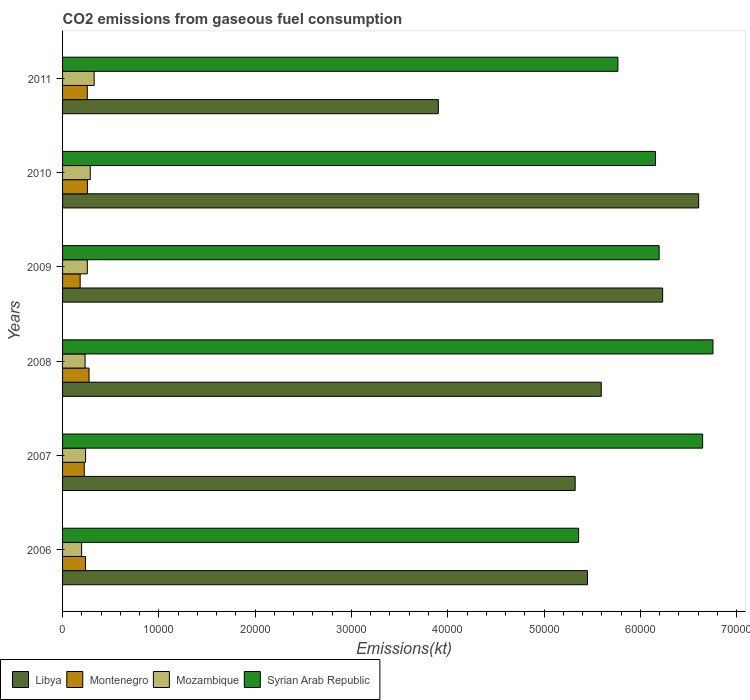How many different coloured bars are there?
Your response must be concise. 4. Are the number of bars per tick equal to the number of legend labels?
Your response must be concise. Yes. In how many cases, is the number of bars for a given year not equal to the number of legend labels?
Your response must be concise. 0. What is the amount of CO2 emitted in Montenegro in 2010?
Ensure brevity in your answer.  2581.57. Across all years, what is the maximum amount of CO2 emitted in Syrian Arab Republic?
Keep it short and to the point. 6.75e+04. Across all years, what is the minimum amount of CO2 emitted in Montenegro?
Offer a very short reply. 1826.17. In which year was the amount of CO2 emitted in Syrian Arab Republic maximum?
Keep it short and to the point. 2008. What is the total amount of CO2 emitted in Mozambique in the graph?
Provide a short and direct response. 1.54e+04. What is the difference between the amount of CO2 emitted in Montenegro in 2007 and that in 2008?
Your response must be concise. -498.71. What is the difference between the amount of CO2 emitted in Mozambique in 2010 and the amount of CO2 emitted in Montenegro in 2007?
Your answer should be very brief. 623.39. What is the average amount of CO2 emitted in Mozambique per year?
Provide a short and direct response. 2573.01. In the year 2007, what is the difference between the amount of CO2 emitted in Libya and amount of CO2 emitted in Syrian Arab Republic?
Ensure brevity in your answer.  -1.32e+04. In how many years, is the amount of CO2 emitted in Mozambique greater than 2000 kt?
Keep it short and to the point. 5. What is the ratio of the amount of CO2 emitted in Libya in 2008 to that in 2011?
Give a very brief answer. 1.43. What is the difference between the highest and the second highest amount of CO2 emitted in Mozambique?
Provide a succinct answer. 407.04. What is the difference between the highest and the lowest amount of CO2 emitted in Libya?
Keep it short and to the point. 2.70e+04. In how many years, is the amount of CO2 emitted in Montenegro greater than the average amount of CO2 emitted in Montenegro taken over all years?
Give a very brief answer. 3. Is the sum of the amount of CO2 emitted in Syrian Arab Republic in 2008 and 2011 greater than the maximum amount of CO2 emitted in Montenegro across all years?
Make the answer very short. Yes. What does the 3rd bar from the top in 2009 represents?
Provide a succinct answer. Montenegro. What does the 1st bar from the bottom in 2009 represents?
Your answer should be compact. Libya. Is it the case that in every year, the sum of the amount of CO2 emitted in Syrian Arab Republic and amount of CO2 emitted in Montenegro is greater than the amount of CO2 emitted in Mozambique?
Your answer should be compact. Yes. How many bars are there?
Make the answer very short. 24. Are all the bars in the graph horizontal?
Ensure brevity in your answer.  Yes. How many years are there in the graph?
Your answer should be compact. 6. What is the difference between two consecutive major ticks on the X-axis?
Provide a succinct answer. 10000. Does the graph contain any zero values?
Keep it short and to the point. No. Where does the legend appear in the graph?
Offer a terse response. Bottom left. How are the legend labels stacked?
Your answer should be very brief. Horizontal. What is the title of the graph?
Give a very brief answer. CO2 emissions from gaseous fuel consumption. What is the label or title of the X-axis?
Your answer should be very brief. Emissions(kt). What is the Emissions(kt) in Libya in 2006?
Make the answer very short. 5.45e+04. What is the Emissions(kt) in Montenegro in 2006?
Ensure brevity in your answer.  2383.55. What is the Emissions(kt) in Mozambique in 2006?
Keep it short and to the point. 1980.18. What is the Emissions(kt) in Syrian Arab Republic in 2006?
Your response must be concise. 5.36e+04. What is the Emissions(kt) in Libya in 2007?
Your response must be concise. 5.32e+04. What is the Emissions(kt) of Montenegro in 2007?
Give a very brief answer. 2251.54. What is the Emissions(kt) of Mozambique in 2007?
Provide a succinct answer. 2390.88. What is the Emissions(kt) in Syrian Arab Republic in 2007?
Make the answer very short. 6.65e+04. What is the Emissions(kt) of Libya in 2008?
Provide a short and direct response. 5.59e+04. What is the Emissions(kt) in Montenegro in 2008?
Provide a succinct answer. 2750.25. What is the Emissions(kt) in Mozambique in 2008?
Provide a succinct answer. 2339.55. What is the Emissions(kt) of Syrian Arab Republic in 2008?
Give a very brief answer. 6.75e+04. What is the Emissions(kt) in Libya in 2009?
Offer a terse response. 6.23e+04. What is the Emissions(kt) of Montenegro in 2009?
Keep it short and to the point. 1826.17. What is the Emissions(kt) of Mozambique in 2009?
Ensure brevity in your answer.  2570.57. What is the Emissions(kt) of Syrian Arab Republic in 2009?
Provide a short and direct response. 6.20e+04. What is the Emissions(kt) of Libya in 2010?
Give a very brief answer. 6.61e+04. What is the Emissions(kt) of Montenegro in 2010?
Make the answer very short. 2581.57. What is the Emissions(kt) of Mozambique in 2010?
Offer a terse response. 2874.93. What is the Emissions(kt) in Syrian Arab Republic in 2010?
Your answer should be very brief. 6.16e+04. What is the Emissions(kt) in Libya in 2011?
Provide a succinct answer. 3.90e+04. What is the Emissions(kt) of Montenegro in 2011?
Give a very brief answer. 2570.57. What is the Emissions(kt) in Mozambique in 2011?
Make the answer very short. 3281.97. What is the Emissions(kt) of Syrian Arab Republic in 2011?
Offer a very short reply. 5.77e+04. Across all years, what is the maximum Emissions(kt) of Libya?
Ensure brevity in your answer.  6.61e+04. Across all years, what is the maximum Emissions(kt) of Montenegro?
Your response must be concise. 2750.25. Across all years, what is the maximum Emissions(kt) in Mozambique?
Your response must be concise. 3281.97. Across all years, what is the maximum Emissions(kt) in Syrian Arab Republic?
Your answer should be compact. 6.75e+04. Across all years, what is the minimum Emissions(kt) in Libya?
Your answer should be very brief. 3.90e+04. Across all years, what is the minimum Emissions(kt) of Montenegro?
Offer a terse response. 1826.17. Across all years, what is the minimum Emissions(kt) in Mozambique?
Your answer should be compact. 1980.18. Across all years, what is the minimum Emissions(kt) in Syrian Arab Republic?
Keep it short and to the point. 5.36e+04. What is the total Emissions(kt) in Libya in the graph?
Offer a very short reply. 3.31e+05. What is the total Emissions(kt) of Montenegro in the graph?
Your answer should be compact. 1.44e+04. What is the total Emissions(kt) in Mozambique in the graph?
Your answer should be compact. 1.54e+04. What is the total Emissions(kt) of Syrian Arab Republic in the graph?
Make the answer very short. 3.69e+05. What is the difference between the Emissions(kt) in Libya in 2006 and that in 2007?
Keep it short and to the point. 1279.78. What is the difference between the Emissions(kt) in Montenegro in 2006 and that in 2007?
Offer a terse response. 132.01. What is the difference between the Emissions(kt) in Mozambique in 2006 and that in 2007?
Keep it short and to the point. -410.7. What is the difference between the Emissions(kt) in Syrian Arab Republic in 2006 and that in 2007?
Offer a very short reply. -1.29e+04. What is the difference between the Emissions(kt) of Libya in 2006 and that in 2008?
Give a very brief answer. -1433.8. What is the difference between the Emissions(kt) in Montenegro in 2006 and that in 2008?
Your answer should be compact. -366.7. What is the difference between the Emissions(kt) in Mozambique in 2006 and that in 2008?
Provide a short and direct response. -359.37. What is the difference between the Emissions(kt) of Syrian Arab Republic in 2006 and that in 2008?
Ensure brevity in your answer.  -1.40e+04. What is the difference between the Emissions(kt) of Libya in 2006 and that in 2009?
Offer a very short reply. -7807.04. What is the difference between the Emissions(kt) in Montenegro in 2006 and that in 2009?
Provide a succinct answer. 557.38. What is the difference between the Emissions(kt) of Mozambique in 2006 and that in 2009?
Offer a very short reply. -590.39. What is the difference between the Emissions(kt) of Syrian Arab Republic in 2006 and that in 2009?
Provide a short and direct response. -8364.43. What is the difference between the Emissions(kt) in Libya in 2006 and that in 2010?
Offer a terse response. -1.15e+04. What is the difference between the Emissions(kt) in Montenegro in 2006 and that in 2010?
Your response must be concise. -198.02. What is the difference between the Emissions(kt) of Mozambique in 2006 and that in 2010?
Give a very brief answer. -894.75. What is the difference between the Emissions(kt) in Syrian Arab Republic in 2006 and that in 2010?
Provide a succinct answer. -7986.73. What is the difference between the Emissions(kt) in Libya in 2006 and that in 2011?
Your answer should be very brief. 1.55e+04. What is the difference between the Emissions(kt) in Montenegro in 2006 and that in 2011?
Your answer should be very brief. -187.02. What is the difference between the Emissions(kt) of Mozambique in 2006 and that in 2011?
Offer a terse response. -1301.79. What is the difference between the Emissions(kt) of Syrian Arab Republic in 2006 and that in 2011?
Provide a succinct answer. -4081.37. What is the difference between the Emissions(kt) in Libya in 2007 and that in 2008?
Your answer should be compact. -2713.58. What is the difference between the Emissions(kt) in Montenegro in 2007 and that in 2008?
Give a very brief answer. -498.71. What is the difference between the Emissions(kt) in Mozambique in 2007 and that in 2008?
Provide a succinct answer. 51.34. What is the difference between the Emissions(kt) of Syrian Arab Republic in 2007 and that in 2008?
Your response must be concise. -1074.43. What is the difference between the Emissions(kt) in Libya in 2007 and that in 2009?
Provide a short and direct response. -9086.83. What is the difference between the Emissions(kt) of Montenegro in 2007 and that in 2009?
Make the answer very short. 425.37. What is the difference between the Emissions(kt) of Mozambique in 2007 and that in 2009?
Your answer should be compact. -179.68. What is the difference between the Emissions(kt) in Syrian Arab Republic in 2007 and that in 2009?
Offer a terse response. 4514.08. What is the difference between the Emissions(kt) of Libya in 2007 and that in 2010?
Your response must be concise. -1.28e+04. What is the difference between the Emissions(kt) of Montenegro in 2007 and that in 2010?
Provide a succinct answer. -330.03. What is the difference between the Emissions(kt) in Mozambique in 2007 and that in 2010?
Offer a terse response. -484.04. What is the difference between the Emissions(kt) of Syrian Arab Republic in 2007 and that in 2010?
Your response must be concise. 4891.78. What is the difference between the Emissions(kt) in Libya in 2007 and that in 2011?
Ensure brevity in your answer.  1.42e+04. What is the difference between the Emissions(kt) of Montenegro in 2007 and that in 2011?
Make the answer very short. -319.03. What is the difference between the Emissions(kt) in Mozambique in 2007 and that in 2011?
Offer a terse response. -891.08. What is the difference between the Emissions(kt) in Syrian Arab Republic in 2007 and that in 2011?
Provide a succinct answer. 8797.13. What is the difference between the Emissions(kt) in Libya in 2008 and that in 2009?
Provide a succinct answer. -6373.25. What is the difference between the Emissions(kt) of Montenegro in 2008 and that in 2009?
Your response must be concise. 924.08. What is the difference between the Emissions(kt) in Mozambique in 2008 and that in 2009?
Offer a terse response. -231.02. What is the difference between the Emissions(kt) in Syrian Arab Republic in 2008 and that in 2009?
Your answer should be compact. 5588.51. What is the difference between the Emissions(kt) in Libya in 2008 and that in 2010?
Provide a succinct answer. -1.01e+04. What is the difference between the Emissions(kt) in Montenegro in 2008 and that in 2010?
Keep it short and to the point. 168.68. What is the difference between the Emissions(kt) of Mozambique in 2008 and that in 2010?
Give a very brief answer. -535.38. What is the difference between the Emissions(kt) of Syrian Arab Republic in 2008 and that in 2010?
Offer a terse response. 5966.21. What is the difference between the Emissions(kt) in Libya in 2008 and that in 2011?
Provide a succinct answer. 1.69e+04. What is the difference between the Emissions(kt) of Montenegro in 2008 and that in 2011?
Provide a succinct answer. 179.68. What is the difference between the Emissions(kt) of Mozambique in 2008 and that in 2011?
Make the answer very short. -942.42. What is the difference between the Emissions(kt) of Syrian Arab Republic in 2008 and that in 2011?
Offer a terse response. 9871.56. What is the difference between the Emissions(kt) of Libya in 2009 and that in 2010?
Offer a very short reply. -3740.34. What is the difference between the Emissions(kt) of Montenegro in 2009 and that in 2010?
Offer a terse response. -755.4. What is the difference between the Emissions(kt) of Mozambique in 2009 and that in 2010?
Offer a terse response. -304.36. What is the difference between the Emissions(kt) in Syrian Arab Republic in 2009 and that in 2010?
Provide a succinct answer. 377.7. What is the difference between the Emissions(kt) of Libya in 2009 and that in 2011?
Your answer should be compact. 2.33e+04. What is the difference between the Emissions(kt) of Montenegro in 2009 and that in 2011?
Your answer should be very brief. -744.4. What is the difference between the Emissions(kt) of Mozambique in 2009 and that in 2011?
Provide a short and direct response. -711.4. What is the difference between the Emissions(kt) of Syrian Arab Republic in 2009 and that in 2011?
Make the answer very short. 4283.06. What is the difference between the Emissions(kt) of Libya in 2010 and that in 2011?
Your answer should be compact. 2.70e+04. What is the difference between the Emissions(kt) in Montenegro in 2010 and that in 2011?
Offer a terse response. 11. What is the difference between the Emissions(kt) of Mozambique in 2010 and that in 2011?
Your answer should be very brief. -407.04. What is the difference between the Emissions(kt) in Syrian Arab Republic in 2010 and that in 2011?
Provide a short and direct response. 3905.36. What is the difference between the Emissions(kt) of Libya in 2006 and the Emissions(kt) of Montenegro in 2007?
Give a very brief answer. 5.23e+04. What is the difference between the Emissions(kt) in Libya in 2006 and the Emissions(kt) in Mozambique in 2007?
Ensure brevity in your answer.  5.21e+04. What is the difference between the Emissions(kt) of Libya in 2006 and the Emissions(kt) of Syrian Arab Republic in 2007?
Keep it short and to the point. -1.20e+04. What is the difference between the Emissions(kt) in Montenegro in 2006 and the Emissions(kt) in Mozambique in 2007?
Offer a very short reply. -7.33. What is the difference between the Emissions(kt) of Montenegro in 2006 and the Emissions(kt) of Syrian Arab Republic in 2007?
Your answer should be very brief. -6.41e+04. What is the difference between the Emissions(kt) of Mozambique in 2006 and the Emissions(kt) of Syrian Arab Republic in 2007?
Provide a succinct answer. -6.45e+04. What is the difference between the Emissions(kt) of Libya in 2006 and the Emissions(kt) of Montenegro in 2008?
Provide a succinct answer. 5.18e+04. What is the difference between the Emissions(kt) in Libya in 2006 and the Emissions(kt) in Mozambique in 2008?
Your answer should be very brief. 5.22e+04. What is the difference between the Emissions(kt) of Libya in 2006 and the Emissions(kt) of Syrian Arab Republic in 2008?
Your response must be concise. -1.30e+04. What is the difference between the Emissions(kt) of Montenegro in 2006 and the Emissions(kt) of Mozambique in 2008?
Make the answer very short. 44. What is the difference between the Emissions(kt) of Montenegro in 2006 and the Emissions(kt) of Syrian Arab Republic in 2008?
Ensure brevity in your answer.  -6.52e+04. What is the difference between the Emissions(kt) in Mozambique in 2006 and the Emissions(kt) in Syrian Arab Republic in 2008?
Offer a terse response. -6.56e+04. What is the difference between the Emissions(kt) in Libya in 2006 and the Emissions(kt) in Montenegro in 2009?
Your response must be concise. 5.27e+04. What is the difference between the Emissions(kt) in Libya in 2006 and the Emissions(kt) in Mozambique in 2009?
Your answer should be compact. 5.19e+04. What is the difference between the Emissions(kt) of Libya in 2006 and the Emissions(kt) of Syrian Arab Republic in 2009?
Give a very brief answer. -7444.01. What is the difference between the Emissions(kt) of Montenegro in 2006 and the Emissions(kt) of Mozambique in 2009?
Keep it short and to the point. -187.02. What is the difference between the Emissions(kt) of Montenegro in 2006 and the Emissions(kt) of Syrian Arab Republic in 2009?
Offer a terse response. -5.96e+04. What is the difference between the Emissions(kt) of Mozambique in 2006 and the Emissions(kt) of Syrian Arab Republic in 2009?
Provide a succinct answer. -6.00e+04. What is the difference between the Emissions(kt) in Libya in 2006 and the Emissions(kt) in Montenegro in 2010?
Your answer should be compact. 5.19e+04. What is the difference between the Emissions(kt) of Libya in 2006 and the Emissions(kt) of Mozambique in 2010?
Provide a succinct answer. 5.16e+04. What is the difference between the Emissions(kt) of Libya in 2006 and the Emissions(kt) of Syrian Arab Republic in 2010?
Make the answer very short. -7066.31. What is the difference between the Emissions(kt) in Montenegro in 2006 and the Emissions(kt) in Mozambique in 2010?
Give a very brief answer. -491.38. What is the difference between the Emissions(kt) of Montenegro in 2006 and the Emissions(kt) of Syrian Arab Republic in 2010?
Ensure brevity in your answer.  -5.92e+04. What is the difference between the Emissions(kt) in Mozambique in 2006 and the Emissions(kt) in Syrian Arab Republic in 2010?
Make the answer very short. -5.96e+04. What is the difference between the Emissions(kt) of Libya in 2006 and the Emissions(kt) of Montenegro in 2011?
Make the answer very short. 5.19e+04. What is the difference between the Emissions(kt) of Libya in 2006 and the Emissions(kt) of Mozambique in 2011?
Make the answer very short. 5.12e+04. What is the difference between the Emissions(kt) in Libya in 2006 and the Emissions(kt) in Syrian Arab Republic in 2011?
Ensure brevity in your answer.  -3160.95. What is the difference between the Emissions(kt) in Montenegro in 2006 and the Emissions(kt) in Mozambique in 2011?
Provide a succinct answer. -898.41. What is the difference between the Emissions(kt) in Montenegro in 2006 and the Emissions(kt) in Syrian Arab Republic in 2011?
Your answer should be very brief. -5.53e+04. What is the difference between the Emissions(kt) of Mozambique in 2006 and the Emissions(kt) of Syrian Arab Republic in 2011?
Offer a terse response. -5.57e+04. What is the difference between the Emissions(kt) in Libya in 2007 and the Emissions(kt) in Montenegro in 2008?
Ensure brevity in your answer.  5.05e+04. What is the difference between the Emissions(kt) of Libya in 2007 and the Emissions(kt) of Mozambique in 2008?
Your answer should be compact. 5.09e+04. What is the difference between the Emissions(kt) in Libya in 2007 and the Emissions(kt) in Syrian Arab Republic in 2008?
Provide a succinct answer. -1.43e+04. What is the difference between the Emissions(kt) of Montenegro in 2007 and the Emissions(kt) of Mozambique in 2008?
Ensure brevity in your answer.  -88.01. What is the difference between the Emissions(kt) of Montenegro in 2007 and the Emissions(kt) of Syrian Arab Republic in 2008?
Keep it short and to the point. -6.53e+04. What is the difference between the Emissions(kt) in Mozambique in 2007 and the Emissions(kt) in Syrian Arab Republic in 2008?
Offer a very short reply. -6.52e+04. What is the difference between the Emissions(kt) of Libya in 2007 and the Emissions(kt) of Montenegro in 2009?
Provide a short and direct response. 5.14e+04. What is the difference between the Emissions(kt) of Libya in 2007 and the Emissions(kt) of Mozambique in 2009?
Provide a succinct answer. 5.07e+04. What is the difference between the Emissions(kt) in Libya in 2007 and the Emissions(kt) in Syrian Arab Republic in 2009?
Make the answer very short. -8723.79. What is the difference between the Emissions(kt) of Montenegro in 2007 and the Emissions(kt) of Mozambique in 2009?
Provide a short and direct response. -319.03. What is the difference between the Emissions(kt) in Montenegro in 2007 and the Emissions(kt) in Syrian Arab Republic in 2009?
Ensure brevity in your answer.  -5.97e+04. What is the difference between the Emissions(kt) of Mozambique in 2007 and the Emissions(kt) of Syrian Arab Republic in 2009?
Your response must be concise. -5.96e+04. What is the difference between the Emissions(kt) in Libya in 2007 and the Emissions(kt) in Montenegro in 2010?
Ensure brevity in your answer.  5.06e+04. What is the difference between the Emissions(kt) of Libya in 2007 and the Emissions(kt) of Mozambique in 2010?
Ensure brevity in your answer.  5.04e+04. What is the difference between the Emissions(kt) in Libya in 2007 and the Emissions(kt) in Syrian Arab Republic in 2010?
Provide a short and direct response. -8346.09. What is the difference between the Emissions(kt) in Montenegro in 2007 and the Emissions(kt) in Mozambique in 2010?
Offer a terse response. -623.39. What is the difference between the Emissions(kt) of Montenegro in 2007 and the Emissions(kt) of Syrian Arab Republic in 2010?
Your response must be concise. -5.93e+04. What is the difference between the Emissions(kt) in Mozambique in 2007 and the Emissions(kt) in Syrian Arab Republic in 2010?
Ensure brevity in your answer.  -5.92e+04. What is the difference between the Emissions(kt) in Libya in 2007 and the Emissions(kt) in Montenegro in 2011?
Your answer should be compact. 5.07e+04. What is the difference between the Emissions(kt) of Libya in 2007 and the Emissions(kt) of Mozambique in 2011?
Keep it short and to the point. 4.99e+04. What is the difference between the Emissions(kt) of Libya in 2007 and the Emissions(kt) of Syrian Arab Republic in 2011?
Offer a very short reply. -4440.74. What is the difference between the Emissions(kt) of Montenegro in 2007 and the Emissions(kt) of Mozambique in 2011?
Offer a terse response. -1030.43. What is the difference between the Emissions(kt) of Montenegro in 2007 and the Emissions(kt) of Syrian Arab Republic in 2011?
Offer a terse response. -5.54e+04. What is the difference between the Emissions(kt) of Mozambique in 2007 and the Emissions(kt) of Syrian Arab Republic in 2011?
Offer a very short reply. -5.53e+04. What is the difference between the Emissions(kt) in Libya in 2008 and the Emissions(kt) in Montenegro in 2009?
Make the answer very short. 5.41e+04. What is the difference between the Emissions(kt) of Libya in 2008 and the Emissions(kt) of Mozambique in 2009?
Make the answer very short. 5.34e+04. What is the difference between the Emissions(kt) in Libya in 2008 and the Emissions(kt) in Syrian Arab Republic in 2009?
Offer a very short reply. -6010.21. What is the difference between the Emissions(kt) in Montenegro in 2008 and the Emissions(kt) in Mozambique in 2009?
Make the answer very short. 179.68. What is the difference between the Emissions(kt) of Montenegro in 2008 and the Emissions(kt) of Syrian Arab Republic in 2009?
Provide a succinct answer. -5.92e+04. What is the difference between the Emissions(kt) in Mozambique in 2008 and the Emissions(kt) in Syrian Arab Republic in 2009?
Your response must be concise. -5.96e+04. What is the difference between the Emissions(kt) in Libya in 2008 and the Emissions(kt) in Montenegro in 2010?
Your answer should be very brief. 5.34e+04. What is the difference between the Emissions(kt) in Libya in 2008 and the Emissions(kt) in Mozambique in 2010?
Your answer should be compact. 5.31e+04. What is the difference between the Emissions(kt) in Libya in 2008 and the Emissions(kt) in Syrian Arab Republic in 2010?
Your answer should be compact. -5632.51. What is the difference between the Emissions(kt) of Montenegro in 2008 and the Emissions(kt) of Mozambique in 2010?
Ensure brevity in your answer.  -124.68. What is the difference between the Emissions(kt) of Montenegro in 2008 and the Emissions(kt) of Syrian Arab Republic in 2010?
Give a very brief answer. -5.88e+04. What is the difference between the Emissions(kt) in Mozambique in 2008 and the Emissions(kt) in Syrian Arab Republic in 2010?
Provide a succinct answer. -5.92e+04. What is the difference between the Emissions(kt) in Libya in 2008 and the Emissions(kt) in Montenegro in 2011?
Keep it short and to the point. 5.34e+04. What is the difference between the Emissions(kt) in Libya in 2008 and the Emissions(kt) in Mozambique in 2011?
Provide a succinct answer. 5.27e+04. What is the difference between the Emissions(kt) of Libya in 2008 and the Emissions(kt) of Syrian Arab Republic in 2011?
Your response must be concise. -1727.16. What is the difference between the Emissions(kt) of Montenegro in 2008 and the Emissions(kt) of Mozambique in 2011?
Provide a short and direct response. -531.72. What is the difference between the Emissions(kt) of Montenegro in 2008 and the Emissions(kt) of Syrian Arab Republic in 2011?
Offer a terse response. -5.49e+04. What is the difference between the Emissions(kt) of Mozambique in 2008 and the Emissions(kt) of Syrian Arab Republic in 2011?
Ensure brevity in your answer.  -5.53e+04. What is the difference between the Emissions(kt) in Libya in 2009 and the Emissions(kt) in Montenegro in 2010?
Your response must be concise. 5.97e+04. What is the difference between the Emissions(kt) in Libya in 2009 and the Emissions(kt) in Mozambique in 2010?
Ensure brevity in your answer.  5.94e+04. What is the difference between the Emissions(kt) in Libya in 2009 and the Emissions(kt) in Syrian Arab Republic in 2010?
Your answer should be very brief. 740.73. What is the difference between the Emissions(kt) of Montenegro in 2009 and the Emissions(kt) of Mozambique in 2010?
Give a very brief answer. -1048.76. What is the difference between the Emissions(kt) in Montenegro in 2009 and the Emissions(kt) in Syrian Arab Republic in 2010?
Your response must be concise. -5.98e+04. What is the difference between the Emissions(kt) in Mozambique in 2009 and the Emissions(kt) in Syrian Arab Republic in 2010?
Offer a very short reply. -5.90e+04. What is the difference between the Emissions(kt) of Libya in 2009 and the Emissions(kt) of Montenegro in 2011?
Ensure brevity in your answer.  5.97e+04. What is the difference between the Emissions(kt) of Libya in 2009 and the Emissions(kt) of Mozambique in 2011?
Keep it short and to the point. 5.90e+04. What is the difference between the Emissions(kt) of Libya in 2009 and the Emissions(kt) of Syrian Arab Republic in 2011?
Your answer should be compact. 4646.09. What is the difference between the Emissions(kt) in Montenegro in 2009 and the Emissions(kt) in Mozambique in 2011?
Offer a terse response. -1455.8. What is the difference between the Emissions(kt) of Montenegro in 2009 and the Emissions(kt) of Syrian Arab Republic in 2011?
Ensure brevity in your answer.  -5.58e+04. What is the difference between the Emissions(kt) of Mozambique in 2009 and the Emissions(kt) of Syrian Arab Republic in 2011?
Provide a short and direct response. -5.51e+04. What is the difference between the Emissions(kt) in Libya in 2010 and the Emissions(kt) in Montenegro in 2011?
Ensure brevity in your answer.  6.35e+04. What is the difference between the Emissions(kt) of Libya in 2010 and the Emissions(kt) of Mozambique in 2011?
Ensure brevity in your answer.  6.28e+04. What is the difference between the Emissions(kt) of Libya in 2010 and the Emissions(kt) of Syrian Arab Republic in 2011?
Give a very brief answer. 8386.43. What is the difference between the Emissions(kt) in Montenegro in 2010 and the Emissions(kt) in Mozambique in 2011?
Ensure brevity in your answer.  -700.4. What is the difference between the Emissions(kt) of Montenegro in 2010 and the Emissions(kt) of Syrian Arab Republic in 2011?
Your response must be concise. -5.51e+04. What is the difference between the Emissions(kt) in Mozambique in 2010 and the Emissions(kt) in Syrian Arab Republic in 2011?
Offer a terse response. -5.48e+04. What is the average Emissions(kt) in Libya per year?
Your answer should be compact. 5.52e+04. What is the average Emissions(kt) of Montenegro per year?
Keep it short and to the point. 2393.94. What is the average Emissions(kt) of Mozambique per year?
Make the answer very short. 2573.01. What is the average Emissions(kt) in Syrian Arab Republic per year?
Offer a terse response. 6.15e+04. In the year 2006, what is the difference between the Emissions(kt) in Libya and Emissions(kt) in Montenegro?
Offer a very short reply. 5.21e+04. In the year 2006, what is the difference between the Emissions(kt) of Libya and Emissions(kt) of Mozambique?
Give a very brief answer. 5.25e+04. In the year 2006, what is the difference between the Emissions(kt) of Libya and Emissions(kt) of Syrian Arab Republic?
Your response must be concise. 920.42. In the year 2006, what is the difference between the Emissions(kt) of Montenegro and Emissions(kt) of Mozambique?
Make the answer very short. 403.37. In the year 2006, what is the difference between the Emissions(kt) of Montenegro and Emissions(kt) of Syrian Arab Republic?
Ensure brevity in your answer.  -5.12e+04. In the year 2006, what is the difference between the Emissions(kt) in Mozambique and Emissions(kt) in Syrian Arab Republic?
Your answer should be very brief. -5.16e+04. In the year 2007, what is the difference between the Emissions(kt) in Libya and Emissions(kt) in Montenegro?
Ensure brevity in your answer.  5.10e+04. In the year 2007, what is the difference between the Emissions(kt) of Libya and Emissions(kt) of Mozambique?
Ensure brevity in your answer.  5.08e+04. In the year 2007, what is the difference between the Emissions(kt) in Libya and Emissions(kt) in Syrian Arab Republic?
Give a very brief answer. -1.32e+04. In the year 2007, what is the difference between the Emissions(kt) of Montenegro and Emissions(kt) of Mozambique?
Offer a very short reply. -139.35. In the year 2007, what is the difference between the Emissions(kt) of Montenegro and Emissions(kt) of Syrian Arab Republic?
Make the answer very short. -6.42e+04. In the year 2007, what is the difference between the Emissions(kt) in Mozambique and Emissions(kt) in Syrian Arab Republic?
Provide a succinct answer. -6.41e+04. In the year 2008, what is the difference between the Emissions(kt) in Libya and Emissions(kt) in Montenegro?
Offer a terse response. 5.32e+04. In the year 2008, what is the difference between the Emissions(kt) of Libya and Emissions(kt) of Mozambique?
Provide a short and direct response. 5.36e+04. In the year 2008, what is the difference between the Emissions(kt) of Libya and Emissions(kt) of Syrian Arab Republic?
Your response must be concise. -1.16e+04. In the year 2008, what is the difference between the Emissions(kt) in Montenegro and Emissions(kt) in Mozambique?
Ensure brevity in your answer.  410.7. In the year 2008, what is the difference between the Emissions(kt) of Montenegro and Emissions(kt) of Syrian Arab Republic?
Ensure brevity in your answer.  -6.48e+04. In the year 2008, what is the difference between the Emissions(kt) in Mozambique and Emissions(kt) in Syrian Arab Republic?
Give a very brief answer. -6.52e+04. In the year 2009, what is the difference between the Emissions(kt) of Libya and Emissions(kt) of Montenegro?
Your answer should be compact. 6.05e+04. In the year 2009, what is the difference between the Emissions(kt) of Libya and Emissions(kt) of Mozambique?
Ensure brevity in your answer.  5.97e+04. In the year 2009, what is the difference between the Emissions(kt) in Libya and Emissions(kt) in Syrian Arab Republic?
Your answer should be very brief. 363.03. In the year 2009, what is the difference between the Emissions(kt) of Montenegro and Emissions(kt) of Mozambique?
Offer a very short reply. -744.4. In the year 2009, what is the difference between the Emissions(kt) of Montenegro and Emissions(kt) of Syrian Arab Republic?
Offer a very short reply. -6.01e+04. In the year 2009, what is the difference between the Emissions(kt) in Mozambique and Emissions(kt) in Syrian Arab Republic?
Provide a succinct answer. -5.94e+04. In the year 2010, what is the difference between the Emissions(kt) of Libya and Emissions(kt) of Montenegro?
Keep it short and to the point. 6.35e+04. In the year 2010, what is the difference between the Emissions(kt) in Libya and Emissions(kt) in Mozambique?
Provide a short and direct response. 6.32e+04. In the year 2010, what is the difference between the Emissions(kt) in Libya and Emissions(kt) in Syrian Arab Republic?
Your answer should be very brief. 4481.07. In the year 2010, what is the difference between the Emissions(kt) in Montenegro and Emissions(kt) in Mozambique?
Offer a very short reply. -293.36. In the year 2010, what is the difference between the Emissions(kt) in Montenegro and Emissions(kt) in Syrian Arab Republic?
Give a very brief answer. -5.90e+04. In the year 2010, what is the difference between the Emissions(kt) in Mozambique and Emissions(kt) in Syrian Arab Republic?
Give a very brief answer. -5.87e+04. In the year 2011, what is the difference between the Emissions(kt) in Libya and Emissions(kt) in Montenegro?
Provide a succinct answer. 3.64e+04. In the year 2011, what is the difference between the Emissions(kt) in Libya and Emissions(kt) in Mozambique?
Give a very brief answer. 3.57e+04. In the year 2011, what is the difference between the Emissions(kt) of Libya and Emissions(kt) of Syrian Arab Republic?
Your answer should be very brief. -1.87e+04. In the year 2011, what is the difference between the Emissions(kt) of Montenegro and Emissions(kt) of Mozambique?
Your response must be concise. -711.4. In the year 2011, what is the difference between the Emissions(kt) in Montenegro and Emissions(kt) in Syrian Arab Republic?
Make the answer very short. -5.51e+04. In the year 2011, what is the difference between the Emissions(kt) in Mozambique and Emissions(kt) in Syrian Arab Republic?
Ensure brevity in your answer.  -5.44e+04. What is the ratio of the Emissions(kt) of Libya in 2006 to that in 2007?
Ensure brevity in your answer.  1.02. What is the ratio of the Emissions(kt) in Montenegro in 2006 to that in 2007?
Your answer should be very brief. 1.06. What is the ratio of the Emissions(kt) in Mozambique in 2006 to that in 2007?
Keep it short and to the point. 0.83. What is the ratio of the Emissions(kt) in Syrian Arab Republic in 2006 to that in 2007?
Make the answer very short. 0.81. What is the ratio of the Emissions(kt) in Libya in 2006 to that in 2008?
Your answer should be very brief. 0.97. What is the ratio of the Emissions(kt) of Montenegro in 2006 to that in 2008?
Provide a short and direct response. 0.87. What is the ratio of the Emissions(kt) in Mozambique in 2006 to that in 2008?
Your answer should be compact. 0.85. What is the ratio of the Emissions(kt) of Syrian Arab Republic in 2006 to that in 2008?
Your response must be concise. 0.79. What is the ratio of the Emissions(kt) in Libya in 2006 to that in 2009?
Your response must be concise. 0.87. What is the ratio of the Emissions(kt) in Montenegro in 2006 to that in 2009?
Make the answer very short. 1.31. What is the ratio of the Emissions(kt) in Mozambique in 2006 to that in 2009?
Keep it short and to the point. 0.77. What is the ratio of the Emissions(kt) in Syrian Arab Republic in 2006 to that in 2009?
Keep it short and to the point. 0.86. What is the ratio of the Emissions(kt) of Libya in 2006 to that in 2010?
Your response must be concise. 0.83. What is the ratio of the Emissions(kt) in Montenegro in 2006 to that in 2010?
Make the answer very short. 0.92. What is the ratio of the Emissions(kt) in Mozambique in 2006 to that in 2010?
Your answer should be compact. 0.69. What is the ratio of the Emissions(kt) of Syrian Arab Republic in 2006 to that in 2010?
Make the answer very short. 0.87. What is the ratio of the Emissions(kt) of Libya in 2006 to that in 2011?
Provide a short and direct response. 1.4. What is the ratio of the Emissions(kt) in Montenegro in 2006 to that in 2011?
Offer a very short reply. 0.93. What is the ratio of the Emissions(kt) of Mozambique in 2006 to that in 2011?
Ensure brevity in your answer.  0.6. What is the ratio of the Emissions(kt) in Syrian Arab Republic in 2006 to that in 2011?
Your response must be concise. 0.93. What is the ratio of the Emissions(kt) in Libya in 2007 to that in 2008?
Your response must be concise. 0.95. What is the ratio of the Emissions(kt) in Montenegro in 2007 to that in 2008?
Give a very brief answer. 0.82. What is the ratio of the Emissions(kt) in Mozambique in 2007 to that in 2008?
Ensure brevity in your answer.  1.02. What is the ratio of the Emissions(kt) in Syrian Arab Republic in 2007 to that in 2008?
Ensure brevity in your answer.  0.98. What is the ratio of the Emissions(kt) of Libya in 2007 to that in 2009?
Offer a very short reply. 0.85. What is the ratio of the Emissions(kt) in Montenegro in 2007 to that in 2009?
Provide a short and direct response. 1.23. What is the ratio of the Emissions(kt) in Mozambique in 2007 to that in 2009?
Your answer should be very brief. 0.93. What is the ratio of the Emissions(kt) of Syrian Arab Republic in 2007 to that in 2009?
Ensure brevity in your answer.  1.07. What is the ratio of the Emissions(kt) of Libya in 2007 to that in 2010?
Ensure brevity in your answer.  0.81. What is the ratio of the Emissions(kt) in Montenegro in 2007 to that in 2010?
Your answer should be very brief. 0.87. What is the ratio of the Emissions(kt) of Mozambique in 2007 to that in 2010?
Offer a terse response. 0.83. What is the ratio of the Emissions(kt) of Syrian Arab Republic in 2007 to that in 2010?
Give a very brief answer. 1.08. What is the ratio of the Emissions(kt) of Libya in 2007 to that in 2011?
Make the answer very short. 1.36. What is the ratio of the Emissions(kt) in Montenegro in 2007 to that in 2011?
Offer a terse response. 0.88. What is the ratio of the Emissions(kt) of Mozambique in 2007 to that in 2011?
Offer a very short reply. 0.73. What is the ratio of the Emissions(kt) of Syrian Arab Republic in 2007 to that in 2011?
Offer a terse response. 1.15. What is the ratio of the Emissions(kt) in Libya in 2008 to that in 2009?
Give a very brief answer. 0.9. What is the ratio of the Emissions(kt) in Montenegro in 2008 to that in 2009?
Ensure brevity in your answer.  1.51. What is the ratio of the Emissions(kt) of Mozambique in 2008 to that in 2009?
Your answer should be compact. 0.91. What is the ratio of the Emissions(kt) of Syrian Arab Republic in 2008 to that in 2009?
Provide a succinct answer. 1.09. What is the ratio of the Emissions(kt) of Libya in 2008 to that in 2010?
Your answer should be very brief. 0.85. What is the ratio of the Emissions(kt) in Montenegro in 2008 to that in 2010?
Make the answer very short. 1.07. What is the ratio of the Emissions(kt) in Mozambique in 2008 to that in 2010?
Give a very brief answer. 0.81. What is the ratio of the Emissions(kt) of Syrian Arab Republic in 2008 to that in 2010?
Your answer should be compact. 1.1. What is the ratio of the Emissions(kt) in Libya in 2008 to that in 2011?
Your answer should be compact. 1.43. What is the ratio of the Emissions(kt) in Montenegro in 2008 to that in 2011?
Make the answer very short. 1.07. What is the ratio of the Emissions(kt) in Mozambique in 2008 to that in 2011?
Your answer should be compact. 0.71. What is the ratio of the Emissions(kt) of Syrian Arab Republic in 2008 to that in 2011?
Your answer should be very brief. 1.17. What is the ratio of the Emissions(kt) of Libya in 2009 to that in 2010?
Keep it short and to the point. 0.94. What is the ratio of the Emissions(kt) of Montenegro in 2009 to that in 2010?
Your answer should be very brief. 0.71. What is the ratio of the Emissions(kt) in Mozambique in 2009 to that in 2010?
Keep it short and to the point. 0.89. What is the ratio of the Emissions(kt) of Libya in 2009 to that in 2011?
Give a very brief answer. 1.6. What is the ratio of the Emissions(kt) in Montenegro in 2009 to that in 2011?
Offer a terse response. 0.71. What is the ratio of the Emissions(kt) in Mozambique in 2009 to that in 2011?
Your answer should be compact. 0.78. What is the ratio of the Emissions(kt) of Syrian Arab Republic in 2009 to that in 2011?
Offer a terse response. 1.07. What is the ratio of the Emissions(kt) of Libya in 2010 to that in 2011?
Keep it short and to the point. 1.69. What is the ratio of the Emissions(kt) in Mozambique in 2010 to that in 2011?
Provide a succinct answer. 0.88. What is the ratio of the Emissions(kt) of Syrian Arab Republic in 2010 to that in 2011?
Make the answer very short. 1.07. What is the difference between the highest and the second highest Emissions(kt) of Libya?
Provide a short and direct response. 3740.34. What is the difference between the highest and the second highest Emissions(kt) of Montenegro?
Offer a terse response. 168.68. What is the difference between the highest and the second highest Emissions(kt) in Mozambique?
Your answer should be compact. 407.04. What is the difference between the highest and the second highest Emissions(kt) in Syrian Arab Republic?
Your answer should be compact. 1074.43. What is the difference between the highest and the lowest Emissions(kt) in Libya?
Give a very brief answer. 2.70e+04. What is the difference between the highest and the lowest Emissions(kt) of Montenegro?
Offer a very short reply. 924.08. What is the difference between the highest and the lowest Emissions(kt) in Mozambique?
Provide a short and direct response. 1301.79. What is the difference between the highest and the lowest Emissions(kt) in Syrian Arab Republic?
Offer a terse response. 1.40e+04. 